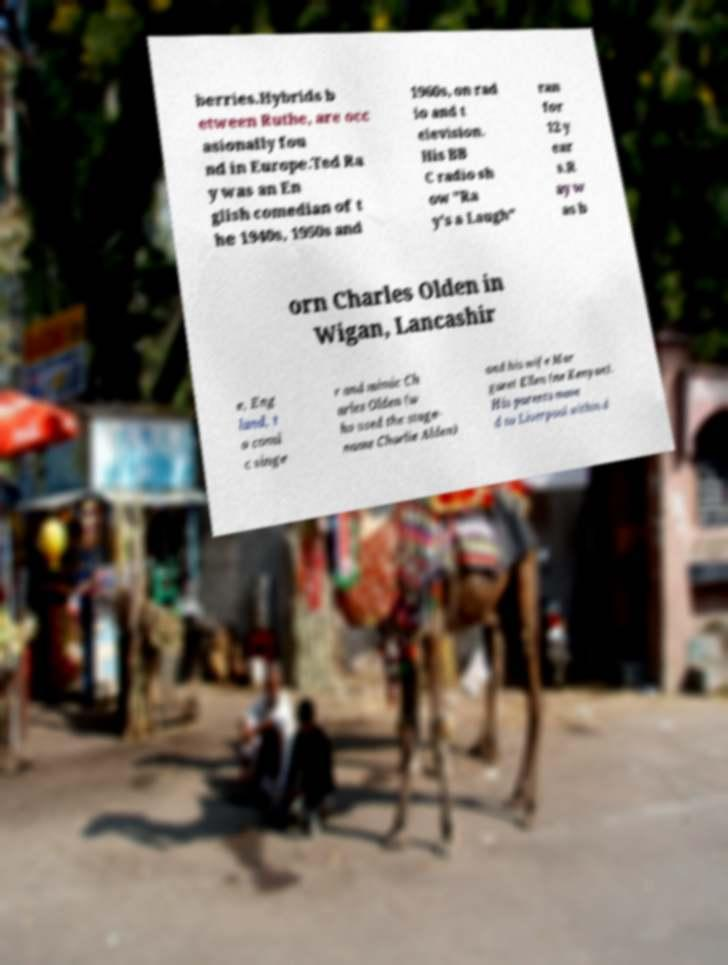Please identify and transcribe the text found in this image. berries.Hybrids b etween Ruthe, are occ asionally fou nd in Europe.Ted Ra y was an En glish comedian of t he 1940s, 1950s and 1960s, on rad io and t elevision. His BB C radio sh ow "Ra y's a Laugh" ran for 12 y ear s.R ay w as b orn Charles Olden in Wigan, Lancashir e, Eng land, t o comi c singe r and mimic Ch arles Olden (w ho used the stage- name Charlie Alden) and his wife Mar garet Ellen (ne Kenyon). His parents move d to Liverpool within d 